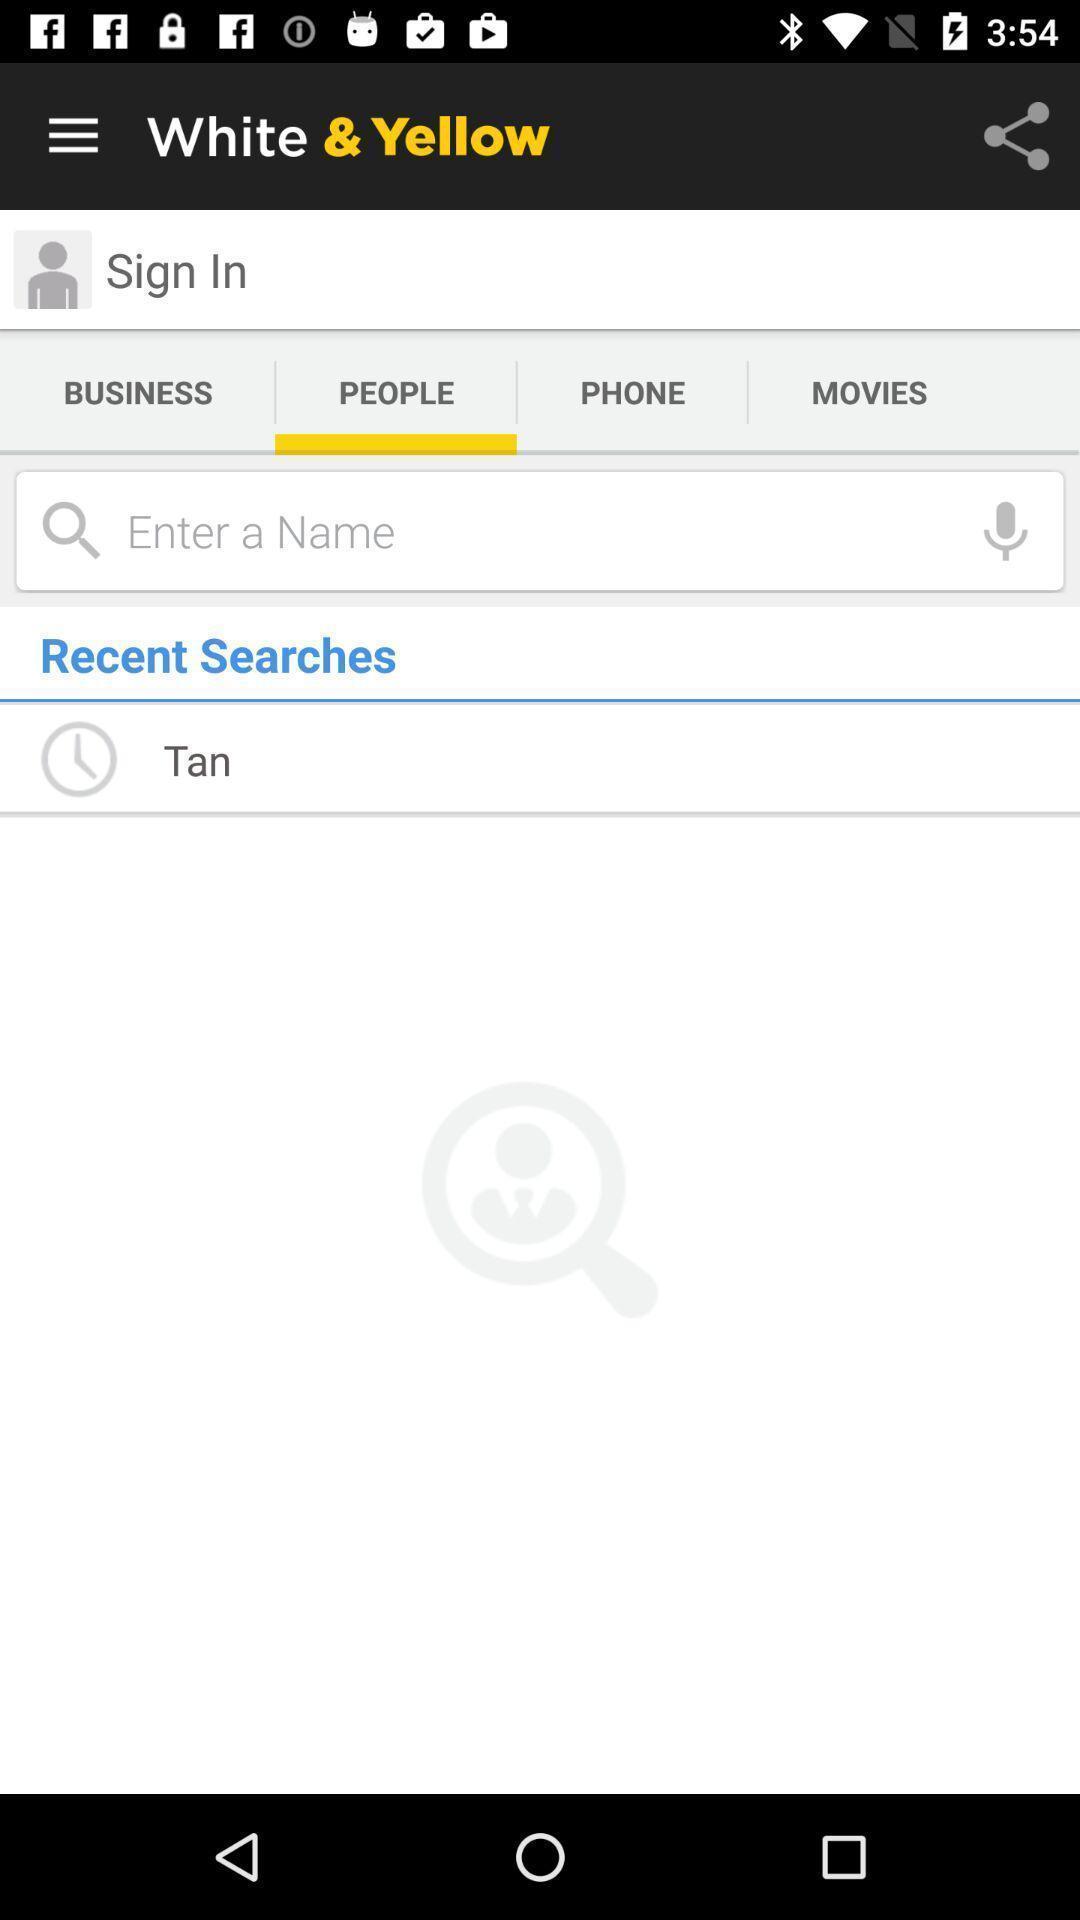Tell me what you see in this picture. Screen displaying a search bar and a sign in option. 